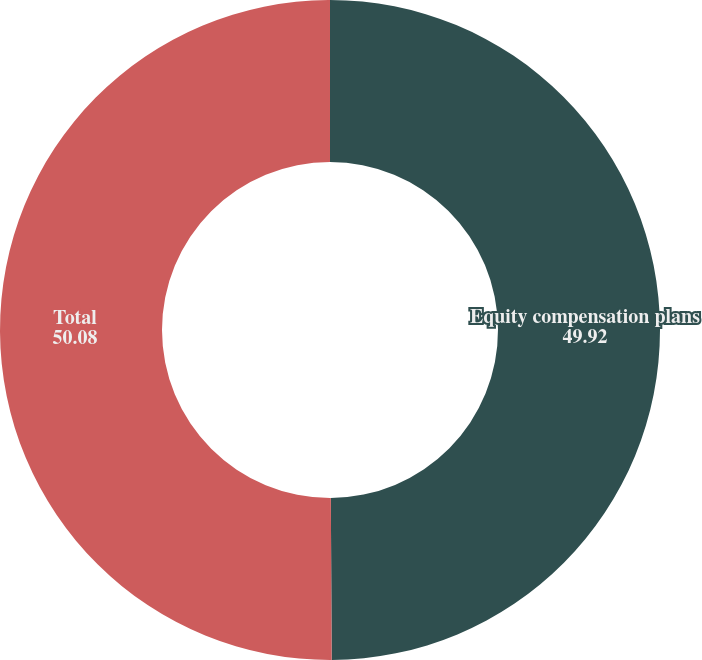Convert chart. <chart><loc_0><loc_0><loc_500><loc_500><pie_chart><fcel>Equity compensation plans<fcel>Total<nl><fcel>49.92%<fcel>50.08%<nl></chart> 